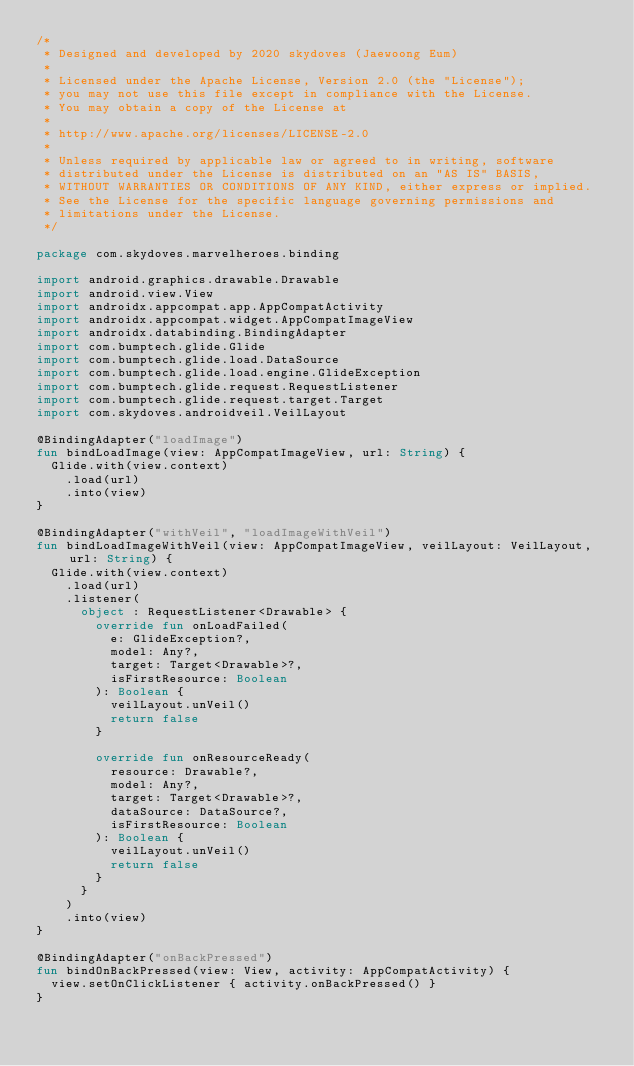<code> <loc_0><loc_0><loc_500><loc_500><_Kotlin_>/*
 * Designed and developed by 2020 skydoves (Jaewoong Eum)
 *
 * Licensed under the Apache License, Version 2.0 (the "License");
 * you may not use this file except in compliance with the License.
 * You may obtain a copy of the License at
 *
 * http://www.apache.org/licenses/LICENSE-2.0
 *
 * Unless required by applicable law or agreed to in writing, software
 * distributed under the License is distributed on an "AS IS" BASIS,
 * WITHOUT WARRANTIES OR CONDITIONS OF ANY KIND, either express or implied.
 * See the License for the specific language governing permissions and
 * limitations under the License.
 */

package com.skydoves.marvelheroes.binding

import android.graphics.drawable.Drawable
import android.view.View
import androidx.appcompat.app.AppCompatActivity
import androidx.appcompat.widget.AppCompatImageView
import androidx.databinding.BindingAdapter
import com.bumptech.glide.Glide
import com.bumptech.glide.load.DataSource
import com.bumptech.glide.load.engine.GlideException
import com.bumptech.glide.request.RequestListener
import com.bumptech.glide.request.target.Target
import com.skydoves.androidveil.VeilLayout

@BindingAdapter("loadImage")
fun bindLoadImage(view: AppCompatImageView, url: String) {
  Glide.with(view.context)
    .load(url)
    .into(view)
}

@BindingAdapter("withVeil", "loadImageWithVeil")
fun bindLoadImageWithVeil(view: AppCompatImageView, veilLayout: VeilLayout, url: String) {
  Glide.with(view.context)
    .load(url)
    .listener(
      object : RequestListener<Drawable> {
        override fun onLoadFailed(
          e: GlideException?,
          model: Any?,
          target: Target<Drawable>?,
          isFirstResource: Boolean
        ): Boolean {
          veilLayout.unVeil()
          return false
        }

        override fun onResourceReady(
          resource: Drawable?,
          model: Any?,
          target: Target<Drawable>?,
          dataSource: DataSource?,
          isFirstResource: Boolean
        ): Boolean {
          veilLayout.unVeil()
          return false
        }
      }
    )
    .into(view)
}

@BindingAdapter("onBackPressed")
fun bindOnBackPressed(view: View, activity: AppCompatActivity) {
  view.setOnClickListener { activity.onBackPressed() }
}
</code> 